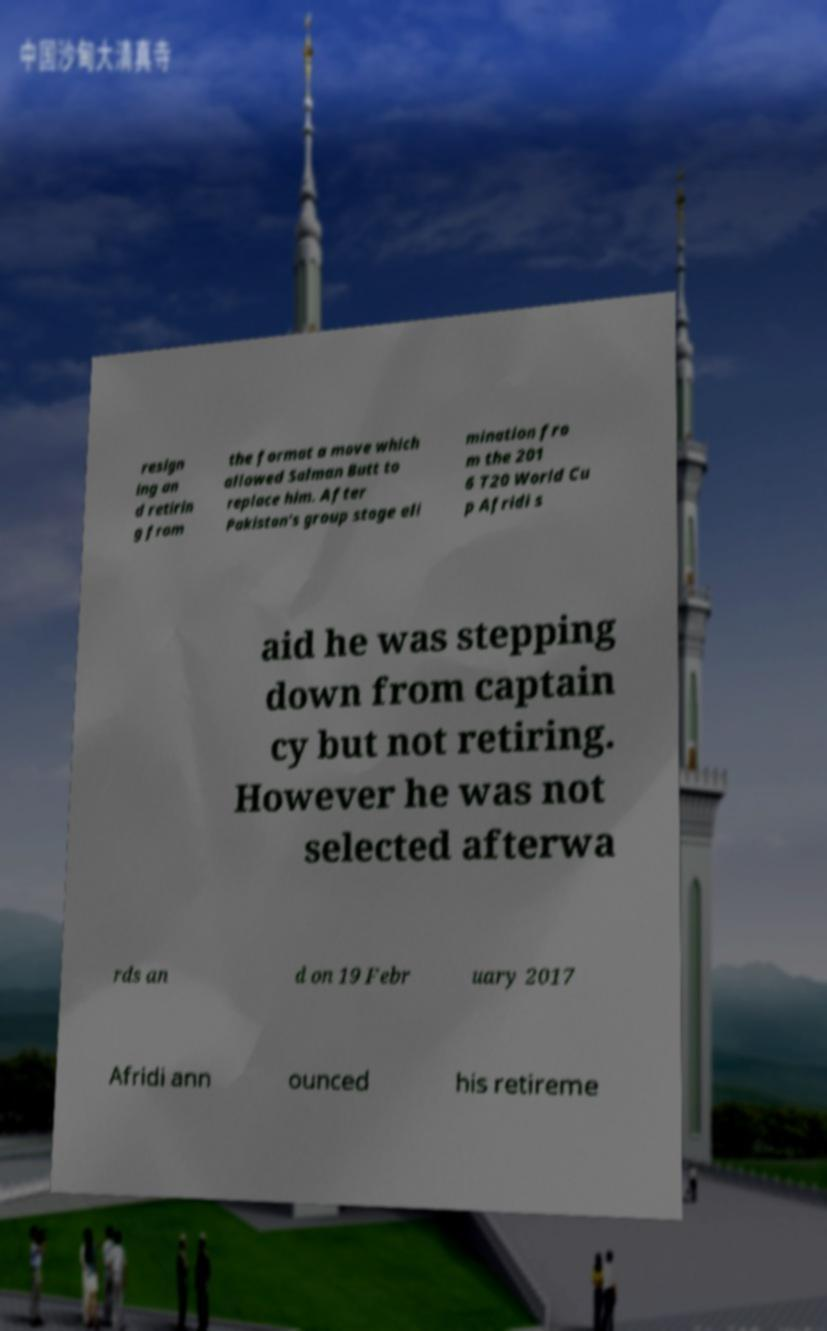Can you accurately transcribe the text from the provided image for me? resign ing an d retirin g from the format a move which allowed Salman Butt to replace him. After Pakistan's group stage eli mination fro m the 201 6 T20 World Cu p Afridi s aid he was stepping down from captain cy but not retiring. However he was not selected afterwa rds an d on 19 Febr uary 2017 Afridi ann ounced his retireme 